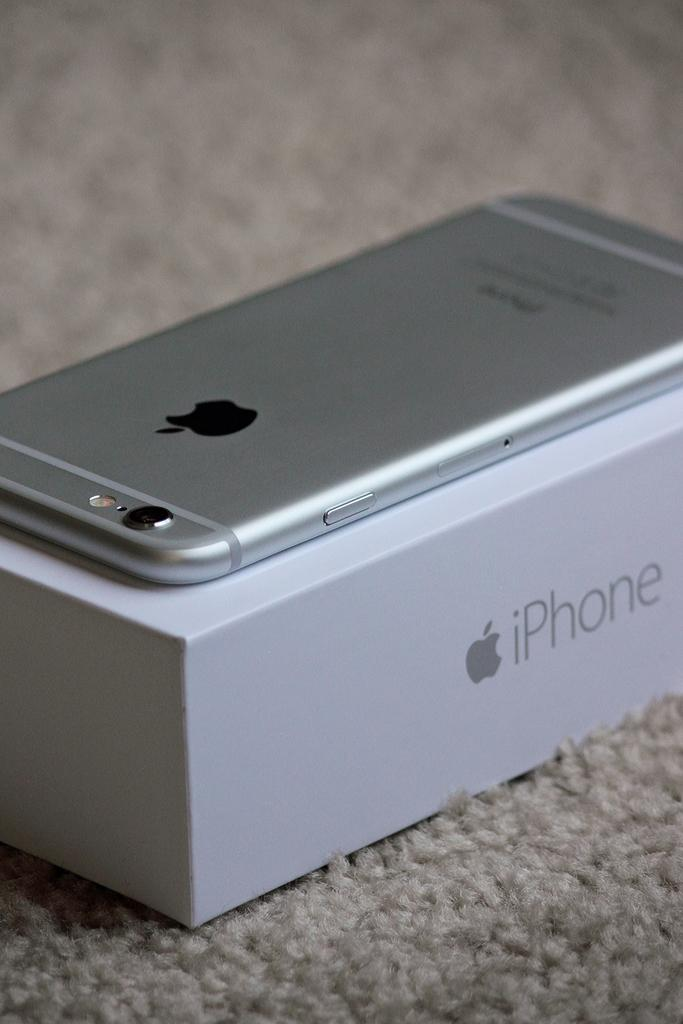<image>
Describe the image concisely. A silver iPhone sits on top of an iPhone box. 